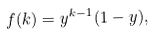Convert formula to latex. <formula><loc_0><loc_0><loc_500><loc_500>f ( k ) = y ^ { k - 1 } ( 1 - y ) ,</formula> 